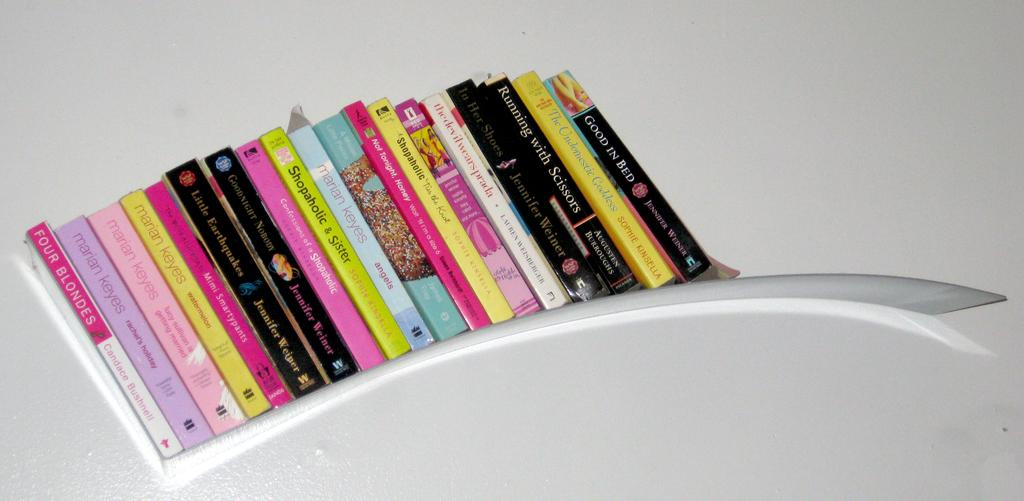What objects can be seen on a shelf in the image? There are books on a shelf in the image. Can you describe the books be found in various colors or sizes in the image? The image does not provide information about the colors or sizes of the books. What might be the purpose of having books on a shelf? The purpose of having books on a shelf could be for storage, organization, or display. How many friends are smiling while riding bikes in the image? There are no friends, smiles, or bikes present in the image; it only features books on a shelf. 